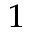Convert formula to latex. <formula><loc_0><loc_0><loc_500><loc_500>^ { 1 }</formula> 